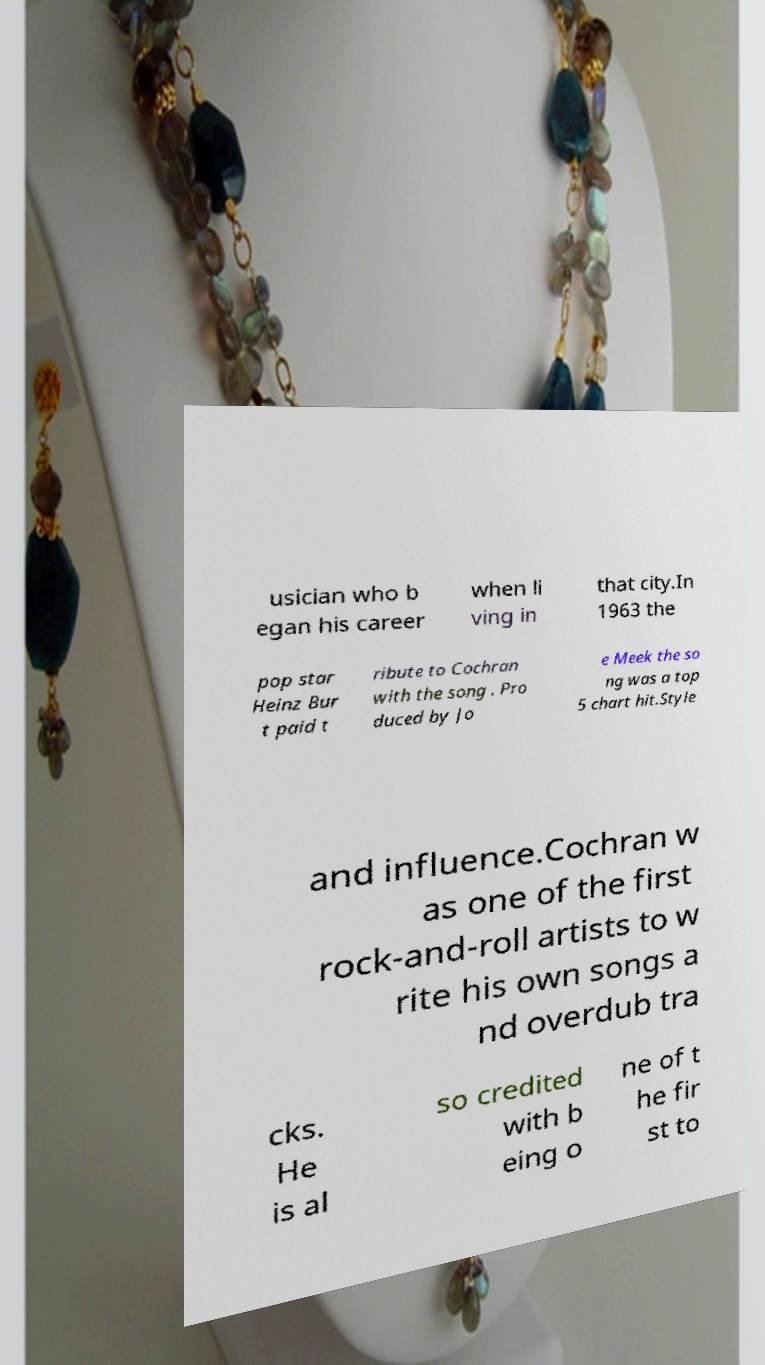I need the written content from this picture converted into text. Can you do that? usician who b egan his career when li ving in that city.In 1963 the pop star Heinz Bur t paid t ribute to Cochran with the song . Pro duced by Jo e Meek the so ng was a top 5 chart hit.Style and influence.Cochran w as one of the first rock-and-roll artists to w rite his own songs a nd overdub tra cks. He is al so credited with b eing o ne of t he fir st to 